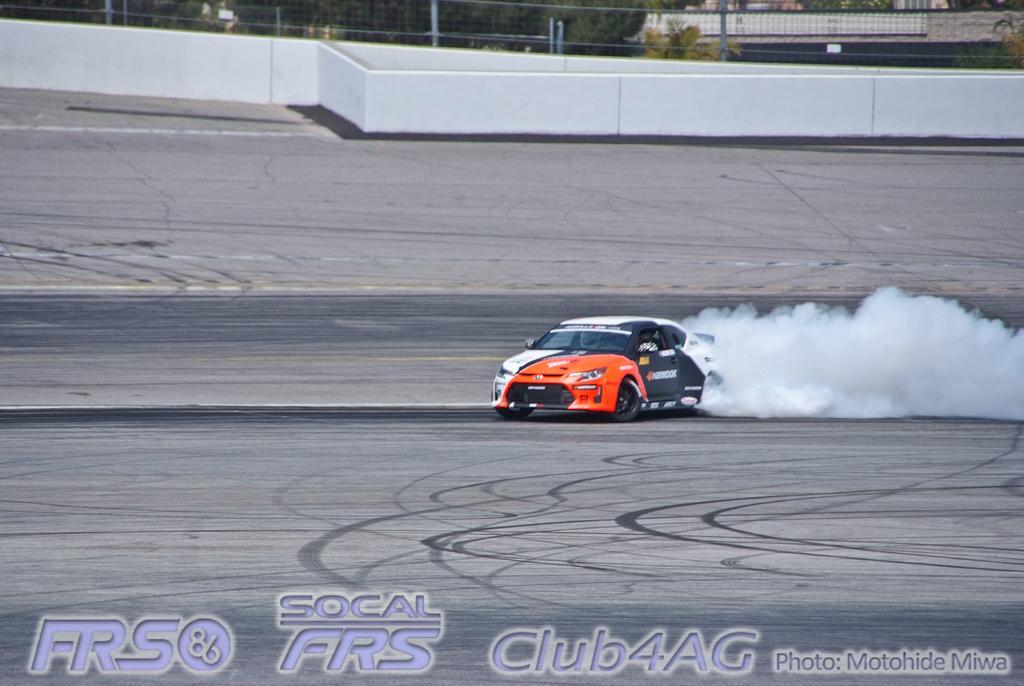Please provide a concise description of this image. There is one person riding a car on the ground as we can see in the middle of this image, and there is a wall in the background. There are some trees at the top of this image. There are some watermarks at the bottom of this image. 